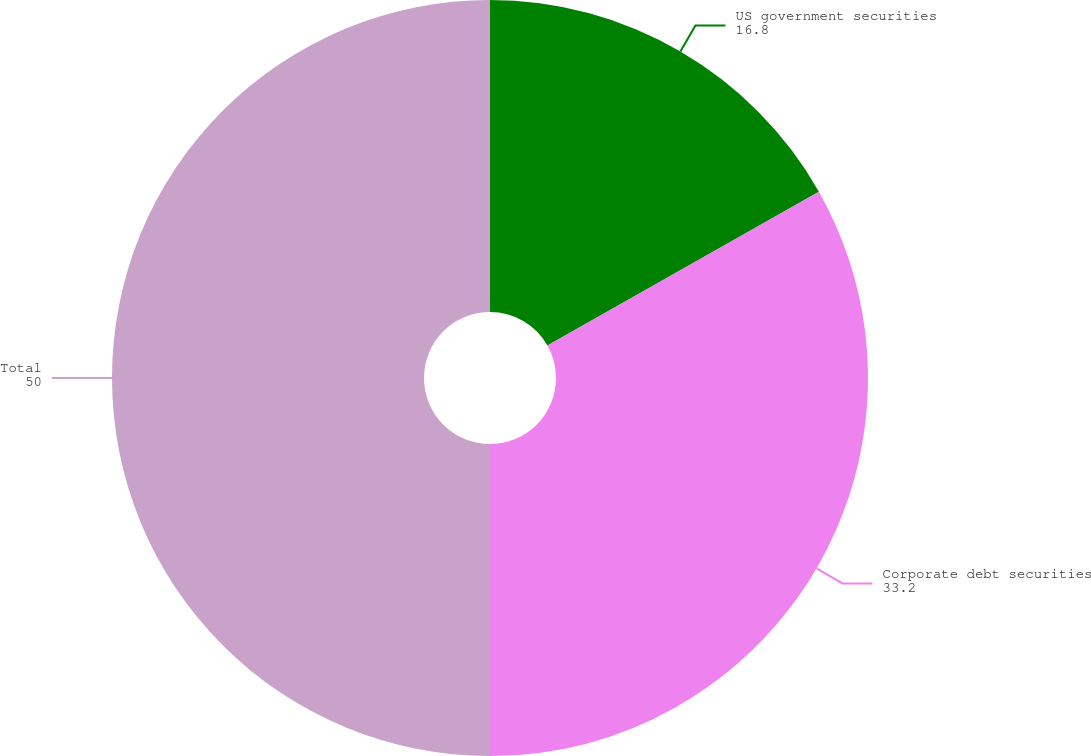<chart> <loc_0><loc_0><loc_500><loc_500><pie_chart><fcel>US government securities<fcel>Corporate debt securities<fcel>Total<nl><fcel>16.8%<fcel>33.2%<fcel>50.0%<nl></chart> 